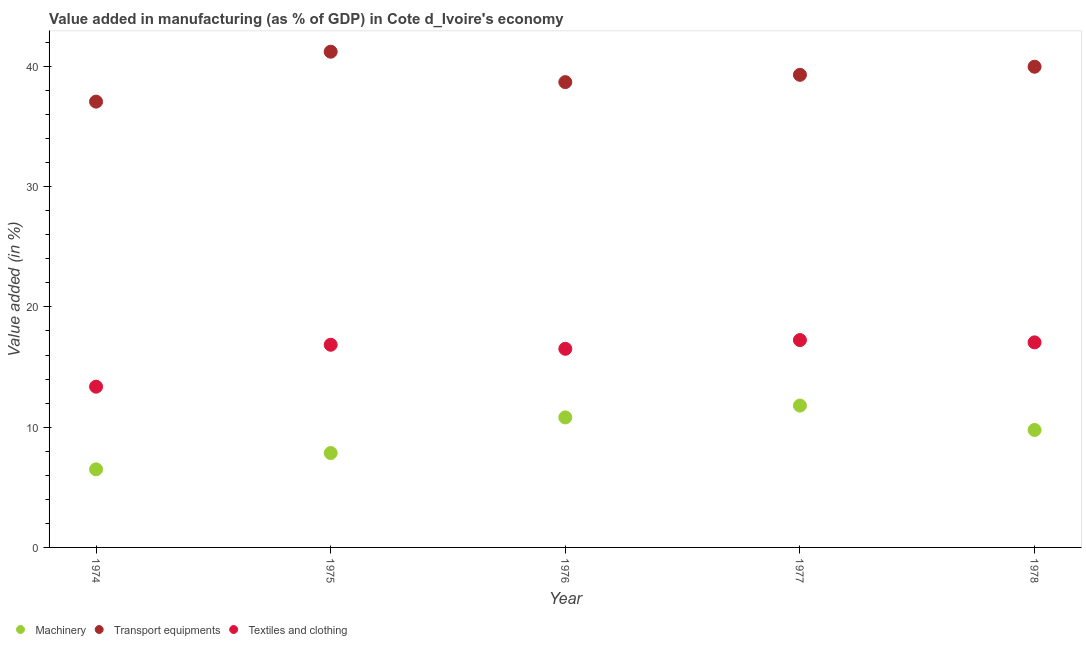Is the number of dotlines equal to the number of legend labels?
Make the answer very short. Yes. What is the value added in manufacturing transport equipments in 1976?
Ensure brevity in your answer.  38.7. Across all years, what is the maximum value added in manufacturing transport equipments?
Provide a succinct answer. 41.23. Across all years, what is the minimum value added in manufacturing textile and clothing?
Keep it short and to the point. 13.37. In which year was the value added in manufacturing machinery maximum?
Provide a succinct answer. 1977. In which year was the value added in manufacturing transport equipments minimum?
Provide a succinct answer. 1974. What is the total value added in manufacturing textile and clothing in the graph?
Offer a very short reply. 81.04. What is the difference between the value added in manufacturing transport equipments in 1974 and that in 1977?
Provide a short and direct response. -2.23. What is the difference between the value added in manufacturing machinery in 1975 and the value added in manufacturing textile and clothing in 1974?
Make the answer very short. -5.52. What is the average value added in manufacturing machinery per year?
Give a very brief answer. 9.34. In the year 1978, what is the difference between the value added in manufacturing textile and clothing and value added in manufacturing transport equipments?
Keep it short and to the point. -22.92. In how many years, is the value added in manufacturing textile and clothing greater than 14 %?
Offer a terse response. 4. What is the ratio of the value added in manufacturing machinery in 1976 to that in 1978?
Your response must be concise. 1.11. What is the difference between the highest and the second highest value added in manufacturing transport equipments?
Provide a short and direct response. 1.25. What is the difference between the highest and the lowest value added in manufacturing transport equipments?
Offer a very short reply. 4.15. Does the value added in manufacturing machinery monotonically increase over the years?
Ensure brevity in your answer.  No. How many years are there in the graph?
Offer a terse response. 5. What is the difference between two consecutive major ticks on the Y-axis?
Your answer should be very brief. 10. Does the graph contain any zero values?
Offer a very short reply. No. Does the graph contain grids?
Your answer should be very brief. No. How many legend labels are there?
Your answer should be very brief. 3. What is the title of the graph?
Your response must be concise. Value added in manufacturing (as % of GDP) in Cote d_Ivoire's economy. What is the label or title of the Y-axis?
Your answer should be very brief. Value added (in %). What is the Value added (in %) in Machinery in 1974?
Your response must be concise. 6.49. What is the Value added (in %) of Transport equipments in 1974?
Give a very brief answer. 37.08. What is the Value added (in %) of Textiles and clothing in 1974?
Give a very brief answer. 13.37. What is the Value added (in %) of Machinery in 1975?
Your answer should be compact. 7.85. What is the Value added (in %) of Transport equipments in 1975?
Your response must be concise. 41.23. What is the Value added (in %) of Textiles and clothing in 1975?
Give a very brief answer. 16.85. What is the Value added (in %) of Machinery in 1976?
Provide a short and direct response. 10.81. What is the Value added (in %) in Transport equipments in 1976?
Offer a very short reply. 38.7. What is the Value added (in %) in Textiles and clothing in 1976?
Keep it short and to the point. 16.52. What is the Value added (in %) in Machinery in 1977?
Your answer should be compact. 11.8. What is the Value added (in %) of Transport equipments in 1977?
Provide a succinct answer. 39.31. What is the Value added (in %) of Textiles and clothing in 1977?
Give a very brief answer. 17.25. What is the Value added (in %) in Machinery in 1978?
Your response must be concise. 9.77. What is the Value added (in %) in Transport equipments in 1978?
Give a very brief answer. 39.98. What is the Value added (in %) of Textiles and clothing in 1978?
Your response must be concise. 17.05. Across all years, what is the maximum Value added (in %) of Machinery?
Provide a short and direct response. 11.8. Across all years, what is the maximum Value added (in %) in Transport equipments?
Make the answer very short. 41.23. Across all years, what is the maximum Value added (in %) in Textiles and clothing?
Offer a very short reply. 17.25. Across all years, what is the minimum Value added (in %) of Machinery?
Offer a terse response. 6.49. Across all years, what is the minimum Value added (in %) of Transport equipments?
Offer a terse response. 37.08. Across all years, what is the minimum Value added (in %) of Textiles and clothing?
Provide a succinct answer. 13.37. What is the total Value added (in %) of Machinery in the graph?
Offer a terse response. 46.72. What is the total Value added (in %) in Transport equipments in the graph?
Give a very brief answer. 196.29. What is the total Value added (in %) in Textiles and clothing in the graph?
Ensure brevity in your answer.  81.04. What is the difference between the Value added (in %) in Machinery in 1974 and that in 1975?
Ensure brevity in your answer.  -1.36. What is the difference between the Value added (in %) in Transport equipments in 1974 and that in 1975?
Ensure brevity in your answer.  -4.15. What is the difference between the Value added (in %) of Textiles and clothing in 1974 and that in 1975?
Give a very brief answer. -3.48. What is the difference between the Value added (in %) in Machinery in 1974 and that in 1976?
Your response must be concise. -4.32. What is the difference between the Value added (in %) in Transport equipments in 1974 and that in 1976?
Ensure brevity in your answer.  -1.62. What is the difference between the Value added (in %) in Textiles and clothing in 1974 and that in 1976?
Keep it short and to the point. -3.15. What is the difference between the Value added (in %) in Machinery in 1974 and that in 1977?
Provide a succinct answer. -5.3. What is the difference between the Value added (in %) in Transport equipments in 1974 and that in 1977?
Offer a terse response. -2.23. What is the difference between the Value added (in %) of Textiles and clothing in 1974 and that in 1977?
Make the answer very short. -3.88. What is the difference between the Value added (in %) in Machinery in 1974 and that in 1978?
Make the answer very short. -3.27. What is the difference between the Value added (in %) in Transport equipments in 1974 and that in 1978?
Your response must be concise. -2.9. What is the difference between the Value added (in %) of Textiles and clothing in 1974 and that in 1978?
Ensure brevity in your answer.  -3.68. What is the difference between the Value added (in %) in Machinery in 1975 and that in 1976?
Give a very brief answer. -2.96. What is the difference between the Value added (in %) in Transport equipments in 1975 and that in 1976?
Your response must be concise. 2.53. What is the difference between the Value added (in %) in Textiles and clothing in 1975 and that in 1976?
Provide a short and direct response. 0.34. What is the difference between the Value added (in %) in Machinery in 1975 and that in 1977?
Your answer should be compact. -3.95. What is the difference between the Value added (in %) of Transport equipments in 1975 and that in 1977?
Provide a short and direct response. 1.92. What is the difference between the Value added (in %) of Textiles and clothing in 1975 and that in 1977?
Offer a very short reply. -0.39. What is the difference between the Value added (in %) of Machinery in 1975 and that in 1978?
Make the answer very short. -1.92. What is the difference between the Value added (in %) of Transport equipments in 1975 and that in 1978?
Keep it short and to the point. 1.25. What is the difference between the Value added (in %) in Textiles and clothing in 1975 and that in 1978?
Offer a terse response. -0.2. What is the difference between the Value added (in %) in Machinery in 1976 and that in 1977?
Your response must be concise. -0.99. What is the difference between the Value added (in %) in Transport equipments in 1976 and that in 1977?
Offer a very short reply. -0.61. What is the difference between the Value added (in %) of Textiles and clothing in 1976 and that in 1977?
Your answer should be compact. -0.73. What is the difference between the Value added (in %) in Machinery in 1976 and that in 1978?
Provide a succinct answer. 1.04. What is the difference between the Value added (in %) in Transport equipments in 1976 and that in 1978?
Offer a very short reply. -1.28. What is the difference between the Value added (in %) of Textiles and clothing in 1976 and that in 1978?
Your answer should be compact. -0.54. What is the difference between the Value added (in %) in Machinery in 1977 and that in 1978?
Provide a succinct answer. 2.03. What is the difference between the Value added (in %) of Transport equipments in 1977 and that in 1978?
Offer a terse response. -0.67. What is the difference between the Value added (in %) of Textiles and clothing in 1977 and that in 1978?
Offer a terse response. 0.19. What is the difference between the Value added (in %) of Machinery in 1974 and the Value added (in %) of Transport equipments in 1975?
Make the answer very short. -34.73. What is the difference between the Value added (in %) in Machinery in 1974 and the Value added (in %) in Textiles and clothing in 1975?
Offer a terse response. -10.36. What is the difference between the Value added (in %) in Transport equipments in 1974 and the Value added (in %) in Textiles and clothing in 1975?
Ensure brevity in your answer.  20.22. What is the difference between the Value added (in %) of Machinery in 1974 and the Value added (in %) of Transport equipments in 1976?
Make the answer very short. -32.2. What is the difference between the Value added (in %) of Machinery in 1974 and the Value added (in %) of Textiles and clothing in 1976?
Provide a short and direct response. -10.02. What is the difference between the Value added (in %) of Transport equipments in 1974 and the Value added (in %) of Textiles and clothing in 1976?
Provide a short and direct response. 20.56. What is the difference between the Value added (in %) in Machinery in 1974 and the Value added (in %) in Transport equipments in 1977?
Offer a terse response. -32.81. What is the difference between the Value added (in %) in Machinery in 1974 and the Value added (in %) in Textiles and clothing in 1977?
Make the answer very short. -10.75. What is the difference between the Value added (in %) of Transport equipments in 1974 and the Value added (in %) of Textiles and clothing in 1977?
Your answer should be very brief. 19.83. What is the difference between the Value added (in %) of Machinery in 1974 and the Value added (in %) of Transport equipments in 1978?
Make the answer very short. -33.48. What is the difference between the Value added (in %) in Machinery in 1974 and the Value added (in %) in Textiles and clothing in 1978?
Provide a succinct answer. -10.56. What is the difference between the Value added (in %) of Transport equipments in 1974 and the Value added (in %) of Textiles and clothing in 1978?
Offer a terse response. 20.02. What is the difference between the Value added (in %) of Machinery in 1975 and the Value added (in %) of Transport equipments in 1976?
Your answer should be compact. -30.85. What is the difference between the Value added (in %) in Machinery in 1975 and the Value added (in %) in Textiles and clothing in 1976?
Your response must be concise. -8.67. What is the difference between the Value added (in %) of Transport equipments in 1975 and the Value added (in %) of Textiles and clothing in 1976?
Give a very brief answer. 24.71. What is the difference between the Value added (in %) in Machinery in 1975 and the Value added (in %) in Transport equipments in 1977?
Your answer should be very brief. -31.46. What is the difference between the Value added (in %) of Machinery in 1975 and the Value added (in %) of Textiles and clothing in 1977?
Keep it short and to the point. -9.4. What is the difference between the Value added (in %) of Transport equipments in 1975 and the Value added (in %) of Textiles and clothing in 1977?
Give a very brief answer. 23.98. What is the difference between the Value added (in %) in Machinery in 1975 and the Value added (in %) in Transport equipments in 1978?
Your answer should be compact. -32.13. What is the difference between the Value added (in %) of Machinery in 1975 and the Value added (in %) of Textiles and clothing in 1978?
Provide a succinct answer. -9.2. What is the difference between the Value added (in %) in Transport equipments in 1975 and the Value added (in %) in Textiles and clothing in 1978?
Keep it short and to the point. 24.17. What is the difference between the Value added (in %) of Machinery in 1976 and the Value added (in %) of Transport equipments in 1977?
Your answer should be very brief. -28.49. What is the difference between the Value added (in %) in Machinery in 1976 and the Value added (in %) in Textiles and clothing in 1977?
Give a very brief answer. -6.43. What is the difference between the Value added (in %) of Transport equipments in 1976 and the Value added (in %) of Textiles and clothing in 1977?
Your answer should be compact. 21.45. What is the difference between the Value added (in %) of Machinery in 1976 and the Value added (in %) of Transport equipments in 1978?
Give a very brief answer. -29.17. What is the difference between the Value added (in %) in Machinery in 1976 and the Value added (in %) in Textiles and clothing in 1978?
Make the answer very short. -6.24. What is the difference between the Value added (in %) of Transport equipments in 1976 and the Value added (in %) of Textiles and clothing in 1978?
Ensure brevity in your answer.  21.64. What is the difference between the Value added (in %) in Machinery in 1977 and the Value added (in %) in Transport equipments in 1978?
Your answer should be compact. -28.18. What is the difference between the Value added (in %) in Machinery in 1977 and the Value added (in %) in Textiles and clothing in 1978?
Ensure brevity in your answer.  -5.26. What is the difference between the Value added (in %) in Transport equipments in 1977 and the Value added (in %) in Textiles and clothing in 1978?
Keep it short and to the point. 22.25. What is the average Value added (in %) of Machinery per year?
Make the answer very short. 9.34. What is the average Value added (in %) in Transport equipments per year?
Make the answer very short. 39.26. What is the average Value added (in %) of Textiles and clothing per year?
Give a very brief answer. 16.21. In the year 1974, what is the difference between the Value added (in %) of Machinery and Value added (in %) of Transport equipments?
Provide a succinct answer. -30.58. In the year 1974, what is the difference between the Value added (in %) in Machinery and Value added (in %) in Textiles and clothing?
Provide a short and direct response. -6.88. In the year 1974, what is the difference between the Value added (in %) in Transport equipments and Value added (in %) in Textiles and clothing?
Your response must be concise. 23.71. In the year 1975, what is the difference between the Value added (in %) of Machinery and Value added (in %) of Transport equipments?
Offer a very short reply. -33.38. In the year 1975, what is the difference between the Value added (in %) of Machinery and Value added (in %) of Textiles and clothing?
Provide a succinct answer. -9. In the year 1975, what is the difference between the Value added (in %) in Transport equipments and Value added (in %) in Textiles and clothing?
Provide a short and direct response. 24.37. In the year 1976, what is the difference between the Value added (in %) in Machinery and Value added (in %) in Transport equipments?
Your answer should be compact. -27.89. In the year 1976, what is the difference between the Value added (in %) of Machinery and Value added (in %) of Textiles and clothing?
Ensure brevity in your answer.  -5.71. In the year 1976, what is the difference between the Value added (in %) of Transport equipments and Value added (in %) of Textiles and clothing?
Your answer should be very brief. 22.18. In the year 1977, what is the difference between the Value added (in %) in Machinery and Value added (in %) in Transport equipments?
Make the answer very short. -27.51. In the year 1977, what is the difference between the Value added (in %) in Machinery and Value added (in %) in Textiles and clothing?
Your answer should be compact. -5.45. In the year 1977, what is the difference between the Value added (in %) in Transport equipments and Value added (in %) in Textiles and clothing?
Your answer should be very brief. 22.06. In the year 1978, what is the difference between the Value added (in %) in Machinery and Value added (in %) in Transport equipments?
Offer a very short reply. -30.21. In the year 1978, what is the difference between the Value added (in %) in Machinery and Value added (in %) in Textiles and clothing?
Ensure brevity in your answer.  -7.29. In the year 1978, what is the difference between the Value added (in %) in Transport equipments and Value added (in %) in Textiles and clothing?
Ensure brevity in your answer.  22.92. What is the ratio of the Value added (in %) of Machinery in 1974 to that in 1975?
Provide a short and direct response. 0.83. What is the ratio of the Value added (in %) in Transport equipments in 1974 to that in 1975?
Ensure brevity in your answer.  0.9. What is the ratio of the Value added (in %) in Textiles and clothing in 1974 to that in 1975?
Your answer should be very brief. 0.79. What is the ratio of the Value added (in %) of Machinery in 1974 to that in 1976?
Your answer should be very brief. 0.6. What is the ratio of the Value added (in %) of Transport equipments in 1974 to that in 1976?
Your response must be concise. 0.96. What is the ratio of the Value added (in %) of Textiles and clothing in 1974 to that in 1976?
Keep it short and to the point. 0.81. What is the ratio of the Value added (in %) of Machinery in 1974 to that in 1977?
Give a very brief answer. 0.55. What is the ratio of the Value added (in %) in Transport equipments in 1974 to that in 1977?
Your answer should be very brief. 0.94. What is the ratio of the Value added (in %) of Textiles and clothing in 1974 to that in 1977?
Offer a terse response. 0.78. What is the ratio of the Value added (in %) in Machinery in 1974 to that in 1978?
Make the answer very short. 0.66. What is the ratio of the Value added (in %) in Transport equipments in 1974 to that in 1978?
Your response must be concise. 0.93. What is the ratio of the Value added (in %) in Textiles and clothing in 1974 to that in 1978?
Keep it short and to the point. 0.78. What is the ratio of the Value added (in %) in Machinery in 1975 to that in 1976?
Your answer should be compact. 0.73. What is the ratio of the Value added (in %) in Transport equipments in 1975 to that in 1976?
Your answer should be very brief. 1.07. What is the ratio of the Value added (in %) in Textiles and clothing in 1975 to that in 1976?
Your answer should be compact. 1.02. What is the ratio of the Value added (in %) of Machinery in 1975 to that in 1977?
Give a very brief answer. 0.67. What is the ratio of the Value added (in %) of Transport equipments in 1975 to that in 1977?
Your response must be concise. 1.05. What is the ratio of the Value added (in %) of Textiles and clothing in 1975 to that in 1977?
Your answer should be compact. 0.98. What is the ratio of the Value added (in %) of Machinery in 1975 to that in 1978?
Keep it short and to the point. 0.8. What is the ratio of the Value added (in %) in Transport equipments in 1975 to that in 1978?
Offer a very short reply. 1.03. What is the ratio of the Value added (in %) in Textiles and clothing in 1975 to that in 1978?
Your answer should be compact. 0.99. What is the ratio of the Value added (in %) of Machinery in 1976 to that in 1977?
Your answer should be very brief. 0.92. What is the ratio of the Value added (in %) of Transport equipments in 1976 to that in 1977?
Your answer should be compact. 0.98. What is the ratio of the Value added (in %) in Textiles and clothing in 1976 to that in 1977?
Your response must be concise. 0.96. What is the ratio of the Value added (in %) of Machinery in 1976 to that in 1978?
Your answer should be compact. 1.11. What is the ratio of the Value added (in %) of Transport equipments in 1976 to that in 1978?
Provide a succinct answer. 0.97. What is the ratio of the Value added (in %) in Textiles and clothing in 1976 to that in 1978?
Your response must be concise. 0.97. What is the ratio of the Value added (in %) of Machinery in 1977 to that in 1978?
Keep it short and to the point. 1.21. What is the ratio of the Value added (in %) of Transport equipments in 1977 to that in 1978?
Provide a succinct answer. 0.98. What is the ratio of the Value added (in %) in Textiles and clothing in 1977 to that in 1978?
Make the answer very short. 1.01. What is the difference between the highest and the second highest Value added (in %) of Machinery?
Keep it short and to the point. 0.99. What is the difference between the highest and the second highest Value added (in %) of Transport equipments?
Keep it short and to the point. 1.25. What is the difference between the highest and the second highest Value added (in %) in Textiles and clothing?
Give a very brief answer. 0.19. What is the difference between the highest and the lowest Value added (in %) in Machinery?
Offer a very short reply. 5.3. What is the difference between the highest and the lowest Value added (in %) in Transport equipments?
Offer a very short reply. 4.15. What is the difference between the highest and the lowest Value added (in %) in Textiles and clothing?
Your answer should be compact. 3.88. 